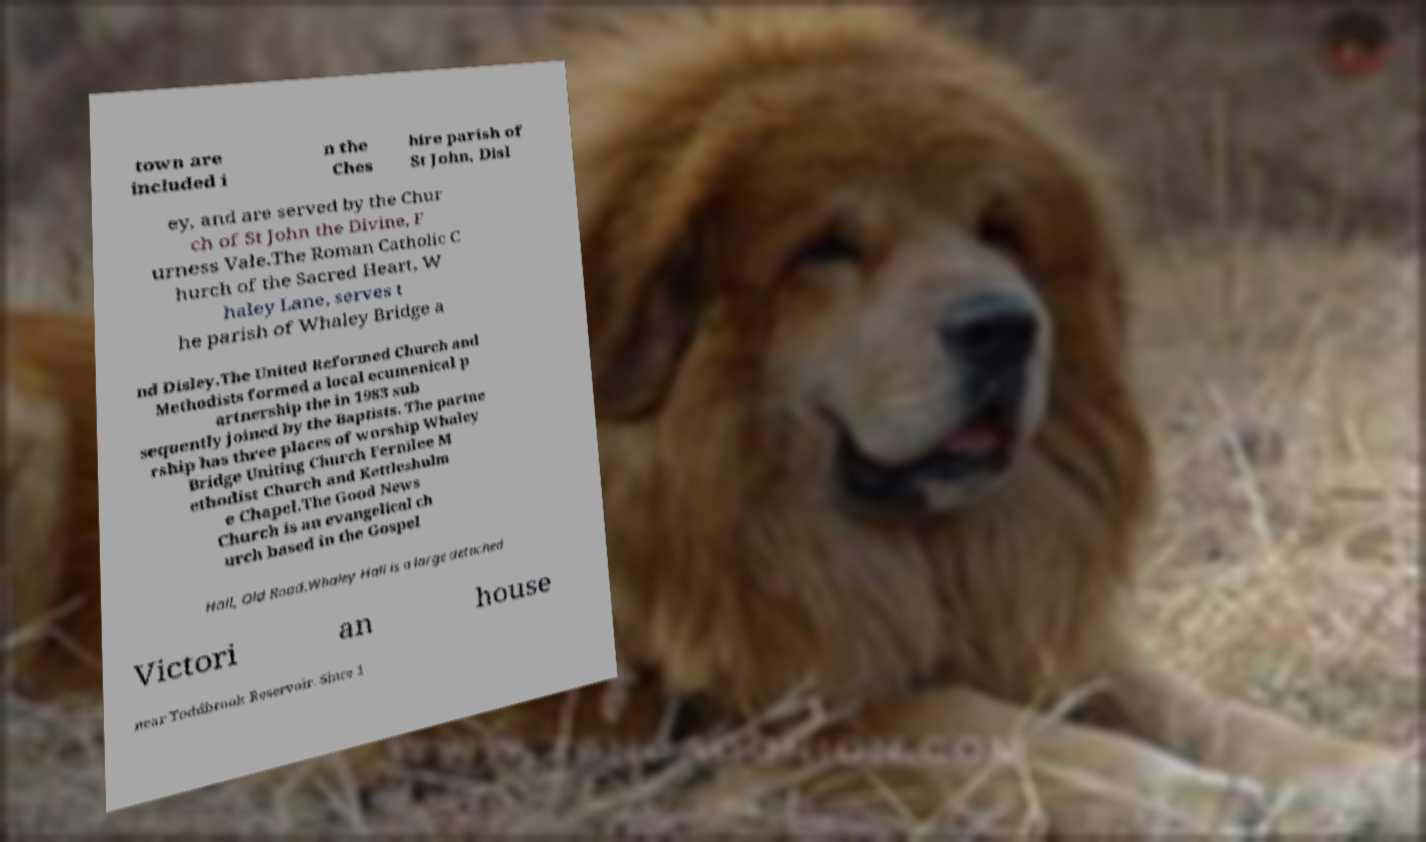Can you read and provide the text displayed in the image?This photo seems to have some interesting text. Can you extract and type it out for me? town are included i n the Ches hire parish of St John, Disl ey, and are served by the Chur ch of St John the Divine, F urness Vale.The Roman Catholic C hurch of the Sacred Heart, W haley Lane, serves t he parish of Whaley Bridge a nd Disley.The United Reformed Church and Methodists formed a local ecumenical p artnership the in 1983 sub sequently joined by the Baptists. The partne rship has three places of worship Whaley Bridge Uniting Church Fernilee M ethodist Church and Kettleshulm e Chapel.The Good News Church is an evangelical ch urch based in the Gospel Hall, Old Road.Whaley Hall is a large detached Victori an house near Toddbrook Reservoir. Since 1 